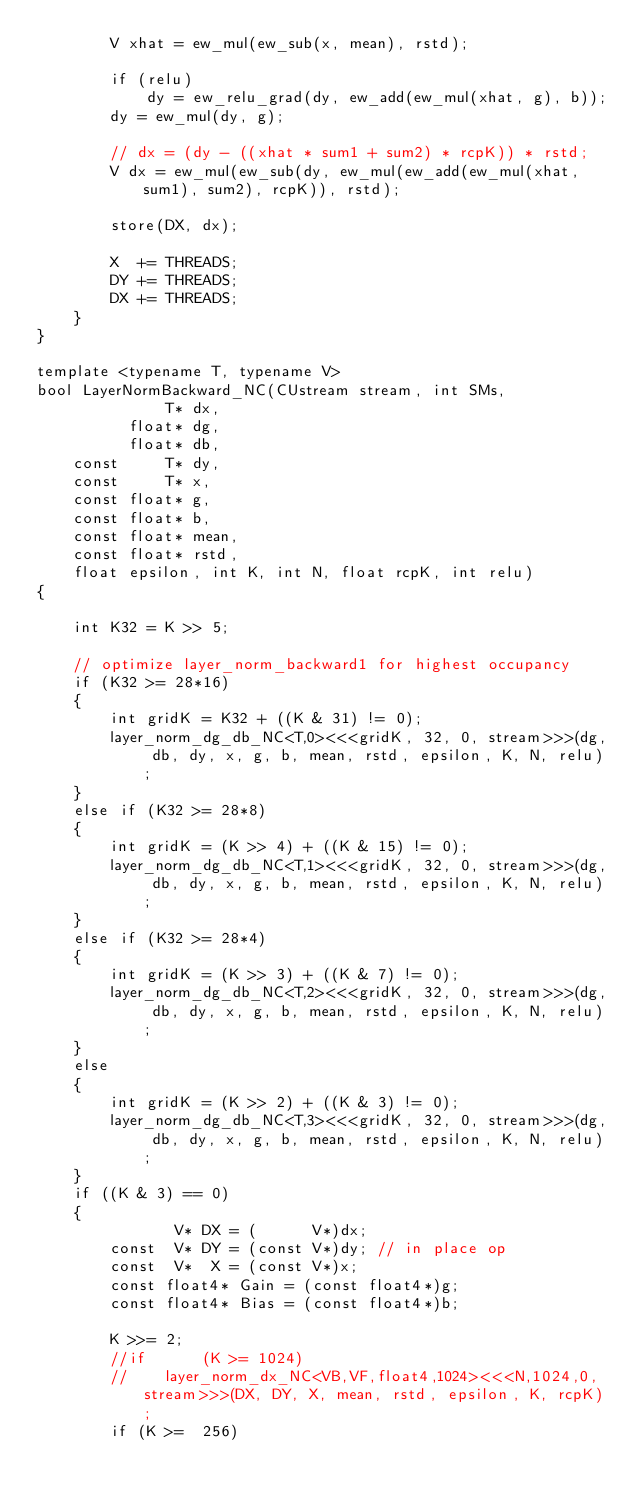Convert code to text. <code><loc_0><loc_0><loc_500><loc_500><_Cuda_>        V xhat = ew_mul(ew_sub(x, mean), rstd);

        if (relu)
            dy = ew_relu_grad(dy, ew_add(ew_mul(xhat, g), b));
        dy = ew_mul(dy, g);

        // dx = (dy - ((xhat * sum1 + sum2) * rcpK)) * rstd;
        V dx = ew_mul(ew_sub(dy, ew_mul(ew_add(ew_mul(xhat, sum1), sum2), rcpK)), rstd);

        store(DX, dx);

        X  += THREADS;
        DY += THREADS;
        DX += THREADS;
    }
}

template <typename T, typename V>
bool LayerNormBackward_NC(CUstream stream, int SMs,
              T* dx,
          float* dg,
          float* db,
    const     T* dy,
    const     T* x,
    const float* g,
    const float* b,
    const float* mean,
    const float* rstd,
    float epsilon, int K, int N, float rcpK, int relu)
{

    int K32 = K >> 5;

    // optimize layer_norm_backward1 for highest occupancy
    if (K32 >= 28*16)
    {
        int gridK = K32 + ((K & 31) != 0);
        layer_norm_dg_db_NC<T,0><<<gridK, 32, 0, stream>>>(dg, db, dy, x, g, b, mean, rstd, epsilon, K, N, relu);
    }
    else if (K32 >= 28*8)
    {
        int gridK = (K >> 4) + ((K & 15) != 0);
        layer_norm_dg_db_NC<T,1><<<gridK, 32, 0, stream>>>(dg, db, dy, x, g, b, mean, rstd, epsilon, K, N, relu);
    }
    else if (K32 >= 28*4)
    {
        int gridK = (K >> 3) + ((K & 7) != 0);
        layer_norm_dg_db_NC<T,2><<<gridK, 32, 0, stream>>>(dg, db, dy, x, g, b, mean, rstd, epsilon, K, N, relu);
    }
    else
    {
        int gridK = (K >> 2) + ((K & 3) != 0);
        layer_norm_dg_db_NC<T,3><<<gridK, 32, 0, stream>>>(dg, db, dy, x, g, b, mean, rstd, epsilon, K, N, relu);
    }
    if ((K & 3) == 0)
    {
               V* DX = (      V*)dx;
        const  V* DY = (const V*)dy; // in place op
        const  V*  X = (const V*)x;
        const float4* Gain = (const float4*)g;
        const float4* Bias = (const float4*)b;

        K >>= 2;
        //if      (K >= 1024)
        //    layer_norm_dx_NC<VB,VF,float4,1024><<<N,1024,0,stream>>>(DX, DY, X, mean, rstd, epsilon, K, rcpK);
        if (K >=  256)</code> 